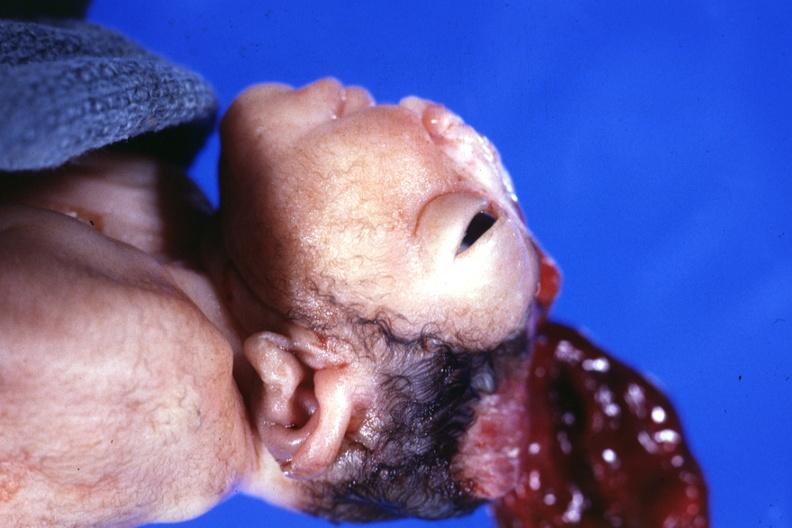does this image show lateral view close-up typical?
Answer the question using a single word or phrase. Yes 